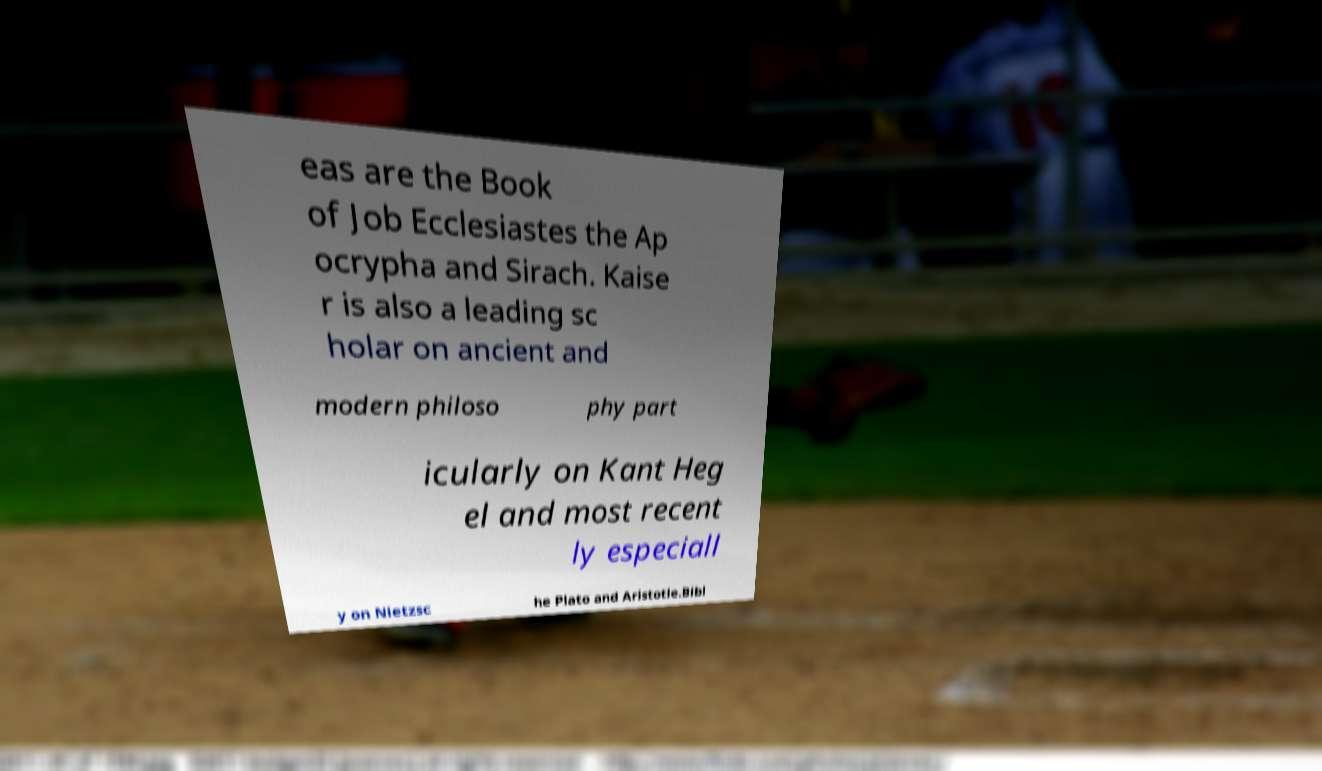There's text embedded in this image that I need extracted. Can you transcribe it verbatim? eas are the Book of Job Ecclesiastes the Ap ocrypha and Sirach. Kaise r is also a leading sc holar on ancient and modern philoso phy part icularly on Kant Heg el and most recent ly especiall y on Nietzsc he Plato and Aristotle.Bibl 